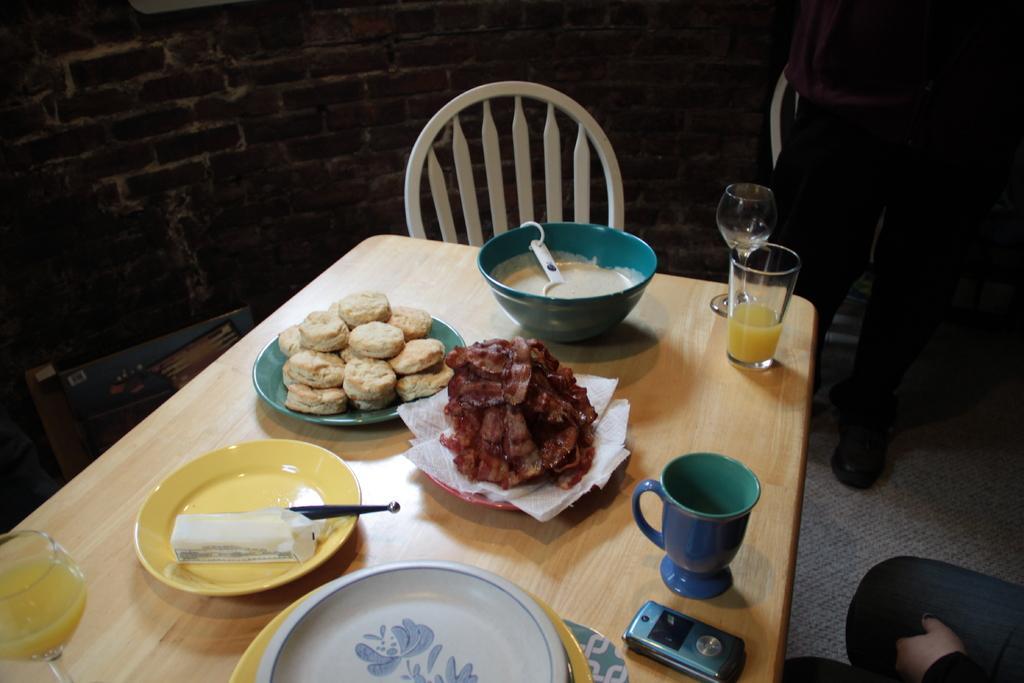Could you give a brief overview of what you see in this image? In this image, we can see some food items on the plate. Here we can see cup, glasses, juice and bowl. Here there is a mobile. All these items are on the wooden table. Here there is a chair. Two people we can see here. Background there is a brick wall, wooden object and some items. 